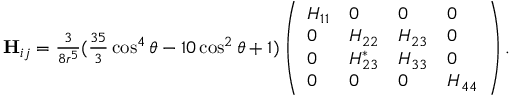Convert formula to latex. <formula><loc_0><loc_0><loc_500><loc_500>\begin{array} { r } { H _ { i j } = \frac { 3 } { 8 r ^ { 5 } } ( \frac { 3 5 } { 3 } \cos ^ { 4 } \theta - 1 0 \cos ^ { 2 } \theta + 1 ) \left ( \begin{array} { l l l l } { H _ { 1 1 } } & { 0 } & { 0 } & { 0 } \\ { 0 } & { H _ { 2 2 } } & { H _ { 2 3 } } & { 0 } \\ { 0 } & { H _ { 2 3 } ^ { * } } & { H _ { 3 3 } } & { 0 } \\ { 0 } & { 0 } & { 0 } & { H _ { 4 4 } } \end{array} \right ) . } \end{array}</formula> 